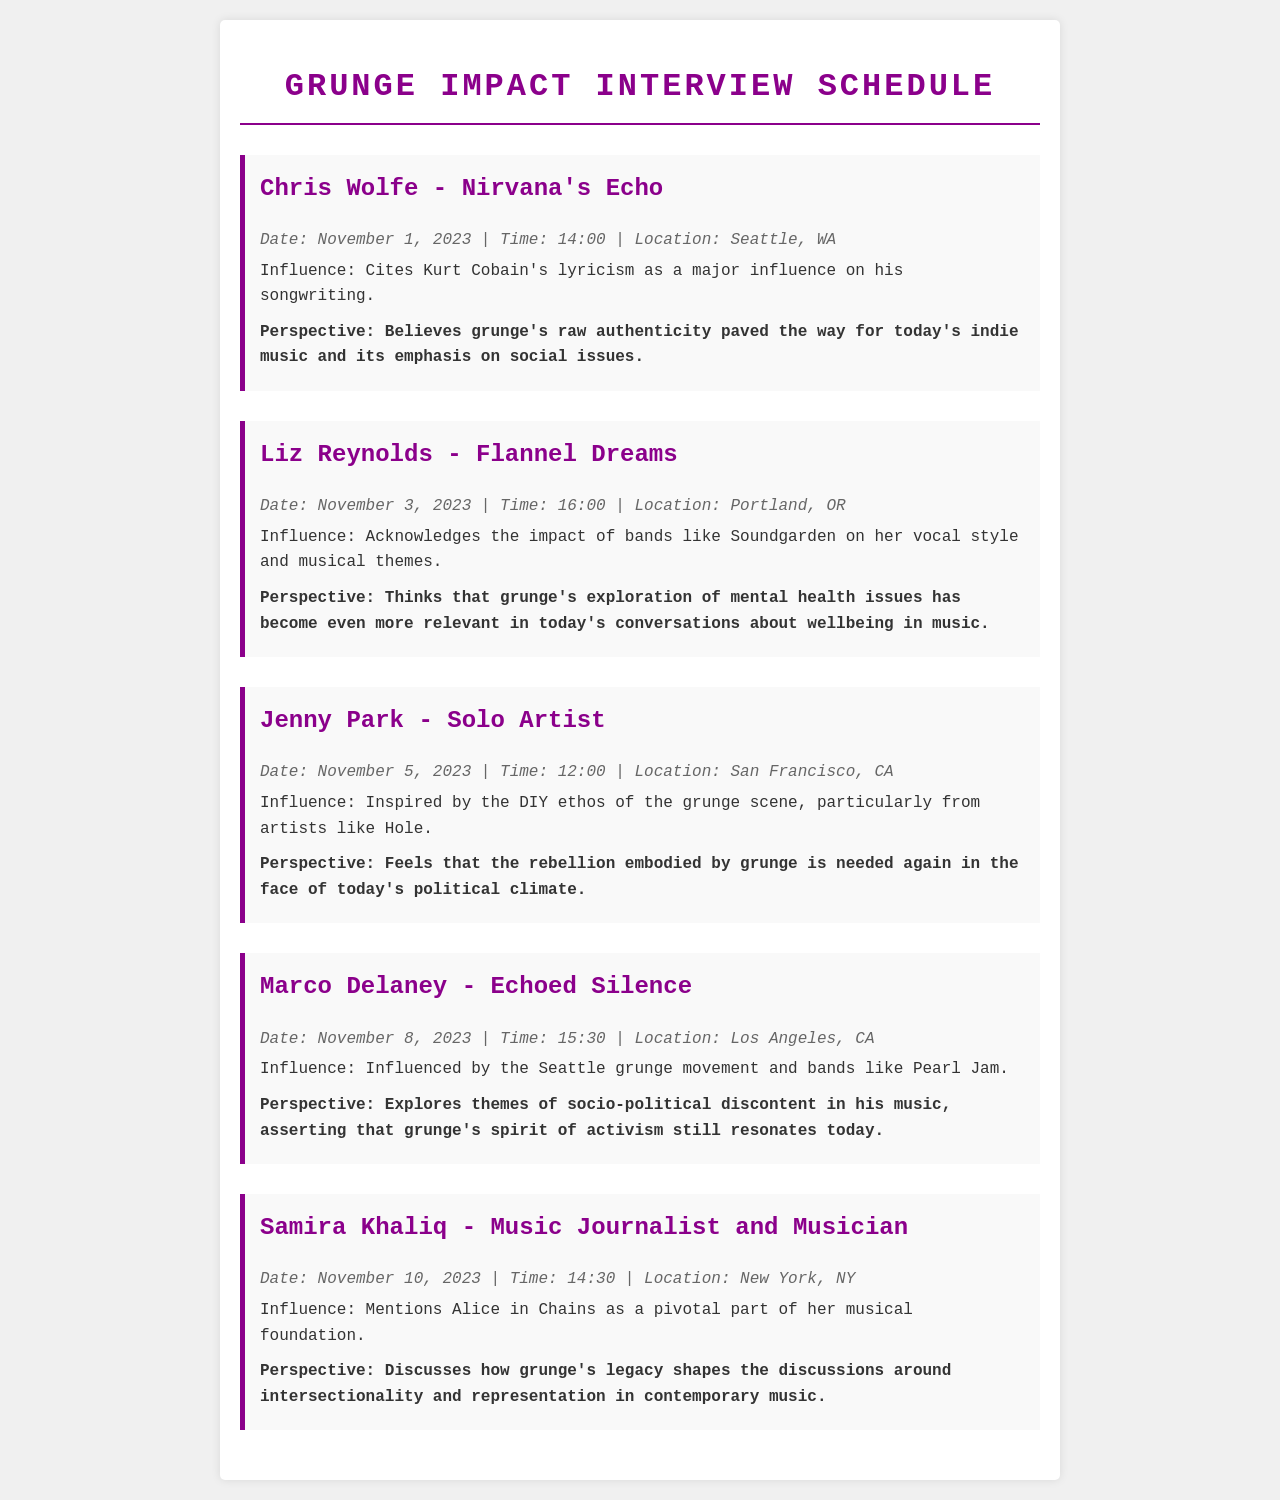What is the name of the first musician interviewed? The first musician interviewed is listed as Chris Wolfe.
Answer: Chris Wolfe When is the interview with Liz Reynolds scheduled? The schedule provides the date and time for Liz Reynolds' interview as November 3, 2023, at 16:00.
Answer: November 3, 2023, 16:00 Which city will the interview with Marco Delaney take place in? The document states that Marco Delaney's interview is set to occur in Los Angeles, CA.
Answer: Los Angeles, CA What song themes does Jenny Park draw inspiration from? Jenny Park cites her inspiration as coming from the DIY ethos of the grunge scene, particularly from artists like Hole.
Answer: DIY ethos What aspect of grunge music does Samira Khaliq explore in her discussion? Samira Khaliq's discussion focuses on how grunge's legacy shapes the conversations around intersectionality and representation in contemporary music.
Answer: Intersectionality and representation How many musicians are scheduled to be interviewed? By counting each musician listed in the document, there are five musicians scheduled for interviews.
Answer: Five On what date does the final interview take place? According to the schedule, the last interview is scheduled for November 10, 2023.
Answer: November 10, 2023 Which band does Liz Reynolds mention as having impacted her vocal style? In the document, Liz Reynolds acknowledges the impact of bands like Soundgarden on her vocal style.
Answer: Soundgarden 